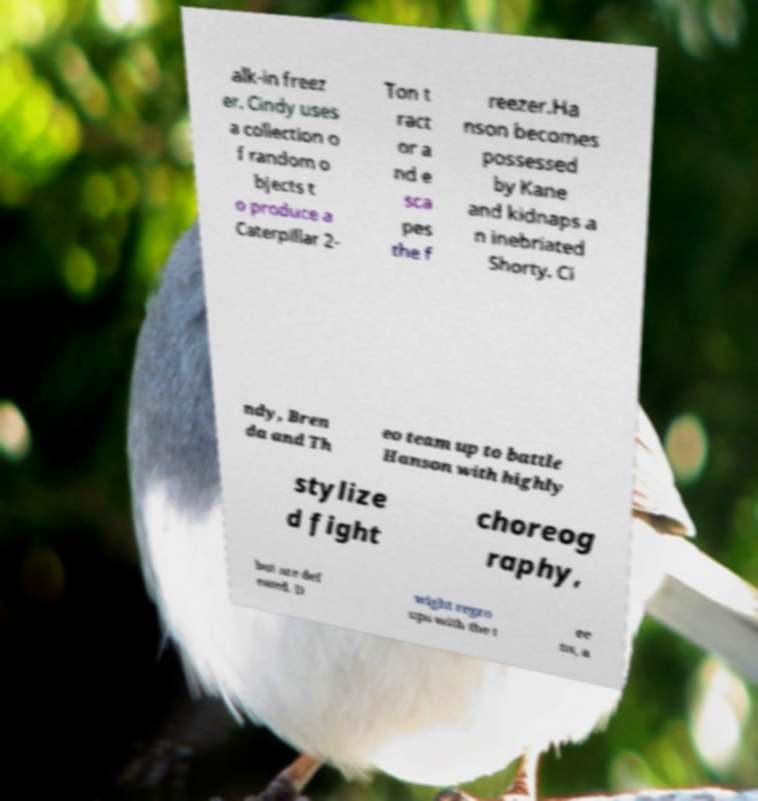Can you accurately transcribe the text from the provided image for me? alk-in freez er. Cindy uses a collection o f random o bjects t o produce a Caterpillar 2- Ton t ract or a nd e sca pes the f reezer.Ha nson becomes possessed by Kane and kidnaps a n inebriated Shorty. Ci ndy, Bren da and Th eo team up to battle Hanson with highly stylize d fight choreog raphy, but are def eated. D wight regro ups with the t ee ns, a 